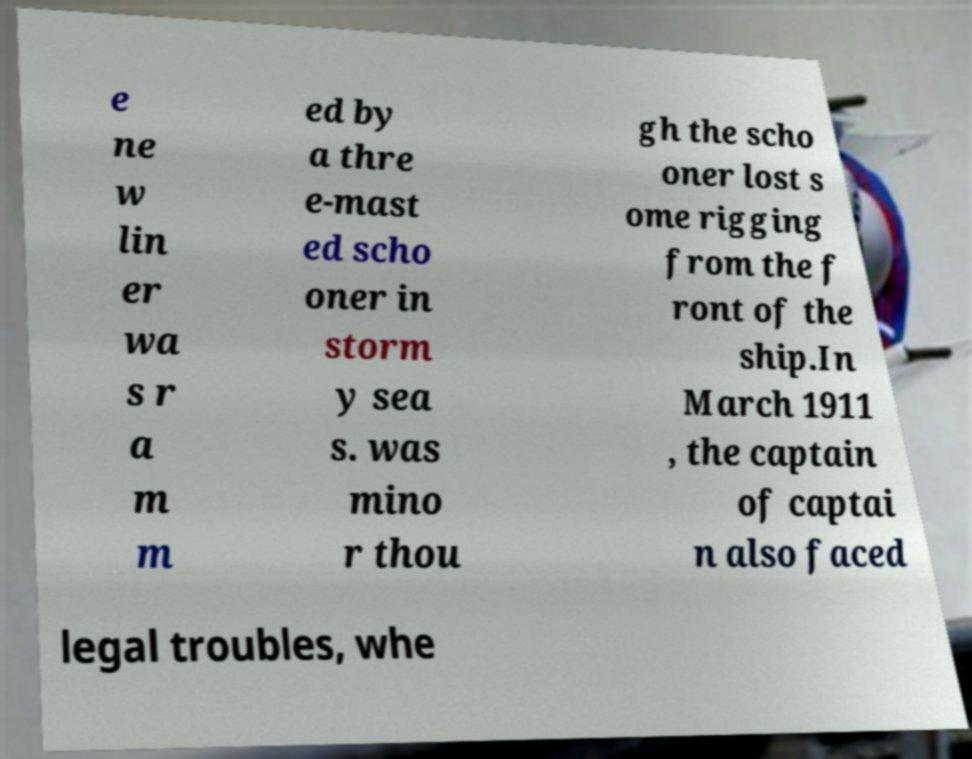Can you accurately transcribe the text from the provided image for me? e ne w lin er wa s r a m m ed by a thre e-mast ed scho oner in storm y sea s. was mino r thou gh the scho oner lost s ome rigging from the f ront of the ship.In March 1911 , the captain of captai n also faced legal troubles, whe 